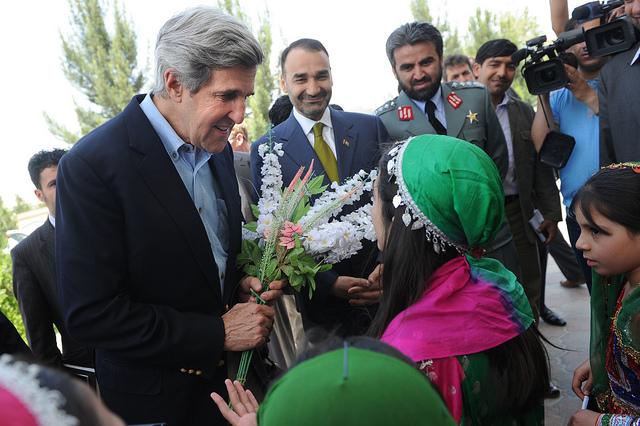What equipment are the men holding?
Concise answer only. Cameras. What is the man holding?
Quick response, please. Flowers. Is the man with the flowers a dignitary?
Give a very brief answer. Yes. What color is the ladies hat?
Short answer required. Green. Is the man Caucasian?
Answer briefly. Yes. Is the item in the man's hand edible?
Answer briefly. No. 